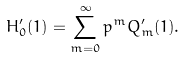Convert formula to latex. <formula><loc_0><loc_0><loc_500><loc_500>H _ { 0 } ^ { \prime } ( 1 ) = \sum _ { m = 0 } ^ { \infty } p ^ { m } Q _ { m } ^ { \prime } ( 1 ) .</formula> 